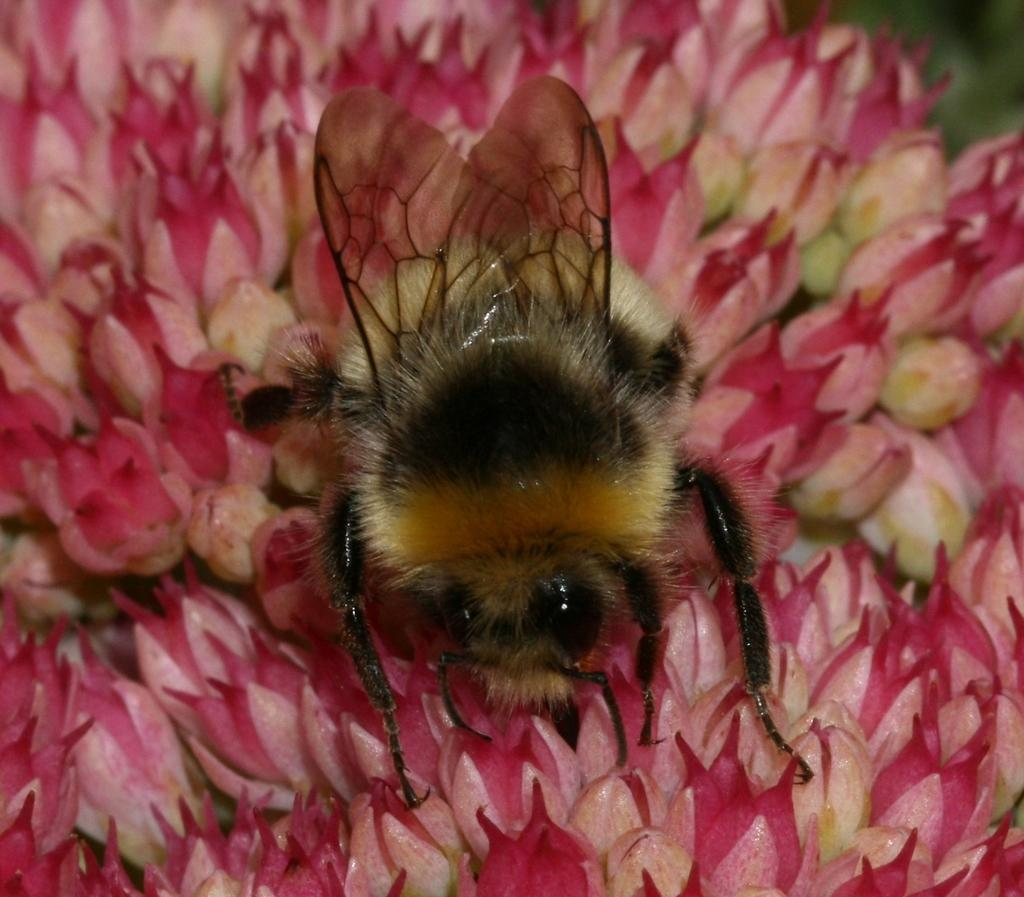What type of insect is in the image? There is a honeybee in the image. What is the honeybee doing in the image? The honeybee is on a flower. What color is the flower that the honeybee is on? The flower is pink in color. What type of cable is connected to the toy in the image? There is no cable or toy present in the image; it features a honeybee on a pink flower. 